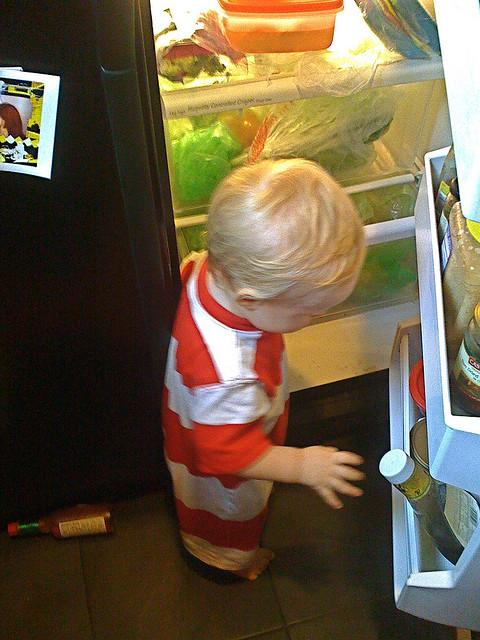What color outfit is the child wearing?

Choices:
A) red
B) pink
C) blue
D) green red 